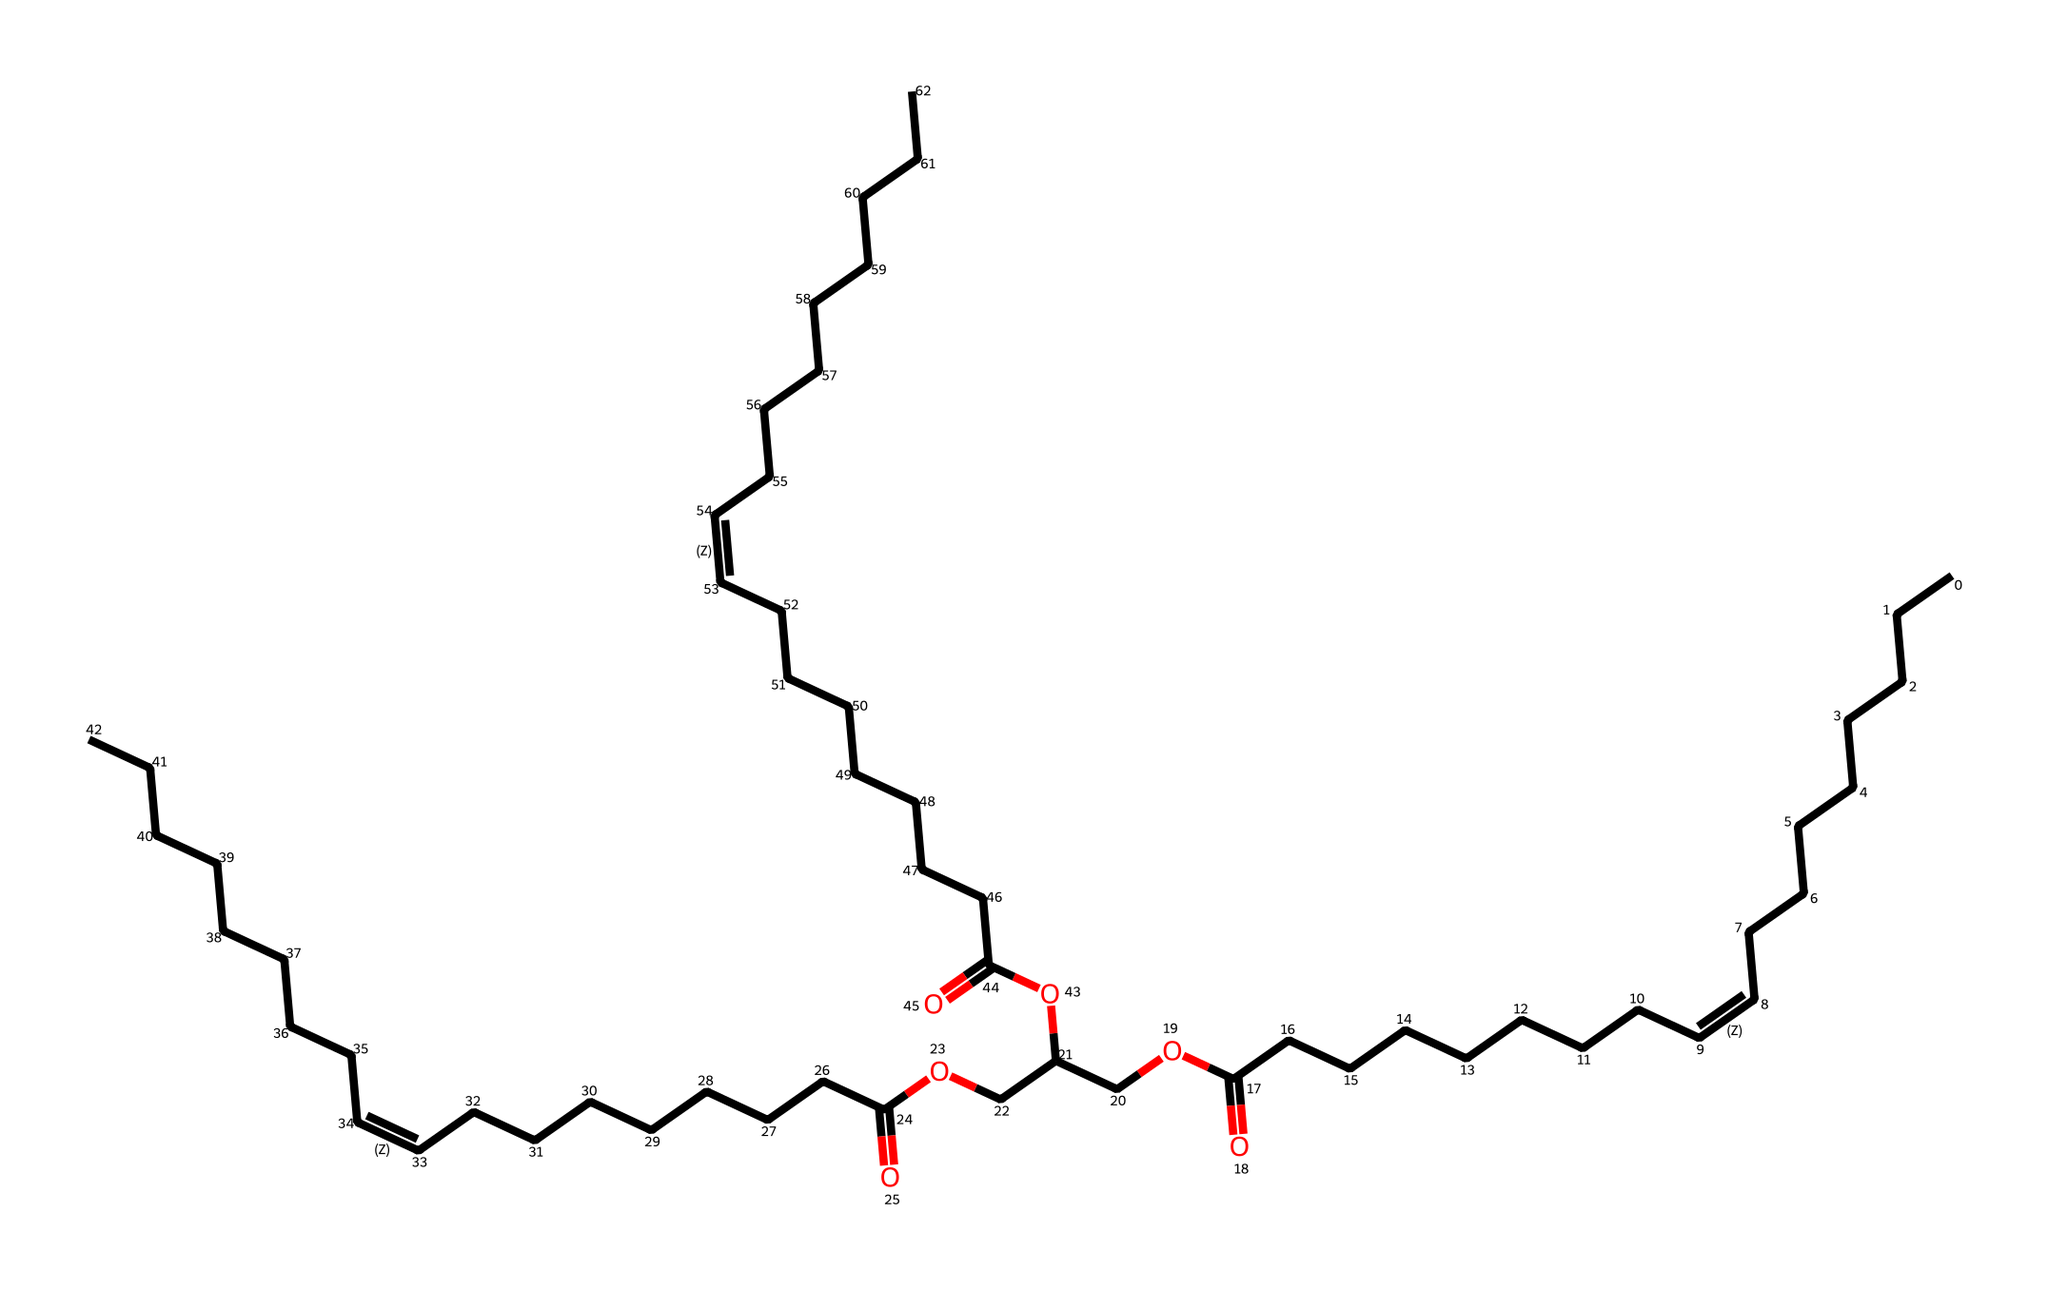What is the total number of carbon atoms in this molecule? The SMILES representation indicates a long chain where each segment corresponds to a carbon atom. By counting the number of 'C' letters before any functional groups or structure separations, we find there are 39 carbon atoms.
Answer: 39 How many double bonds does this molecule contain? The representation includes "/C=C\" which signifies the presence of double bonds. By reviewing the structure closely, we observe there are three such occurrences of double bonds.
Answer: 3 What functional group is indicated by 'O' and 'C(=O)' in this molecule? The 'O' indicates the presence of an oxygen atom, while 'C(=O)' denotes a carbonyl group, typically found in carboxylic acids or esters. Since we see multiple instances of this functional group in the structure, we can conclude it involves esters and carboxylic acids.
Answer: esters and carboxylic acids What type of lipid does this chemical structure represent? The presence of long hydrocarbon chains along with multiple unsaturated bonds suggests this is a type of triglyceride. As such components are typical in oils, it further indicates that this is a plant-based oil.
Answer: triglyceride Which part of this molecule is most likely responsible for its energy content? The long hydrocarbon chains within the structure contain high energy due to saturated and unsaturated bonds. These hydrocarbon chains serve as the main energy reservoir in lipids, including this plant-based oil representation.
Answer: hydrocarbon chains 